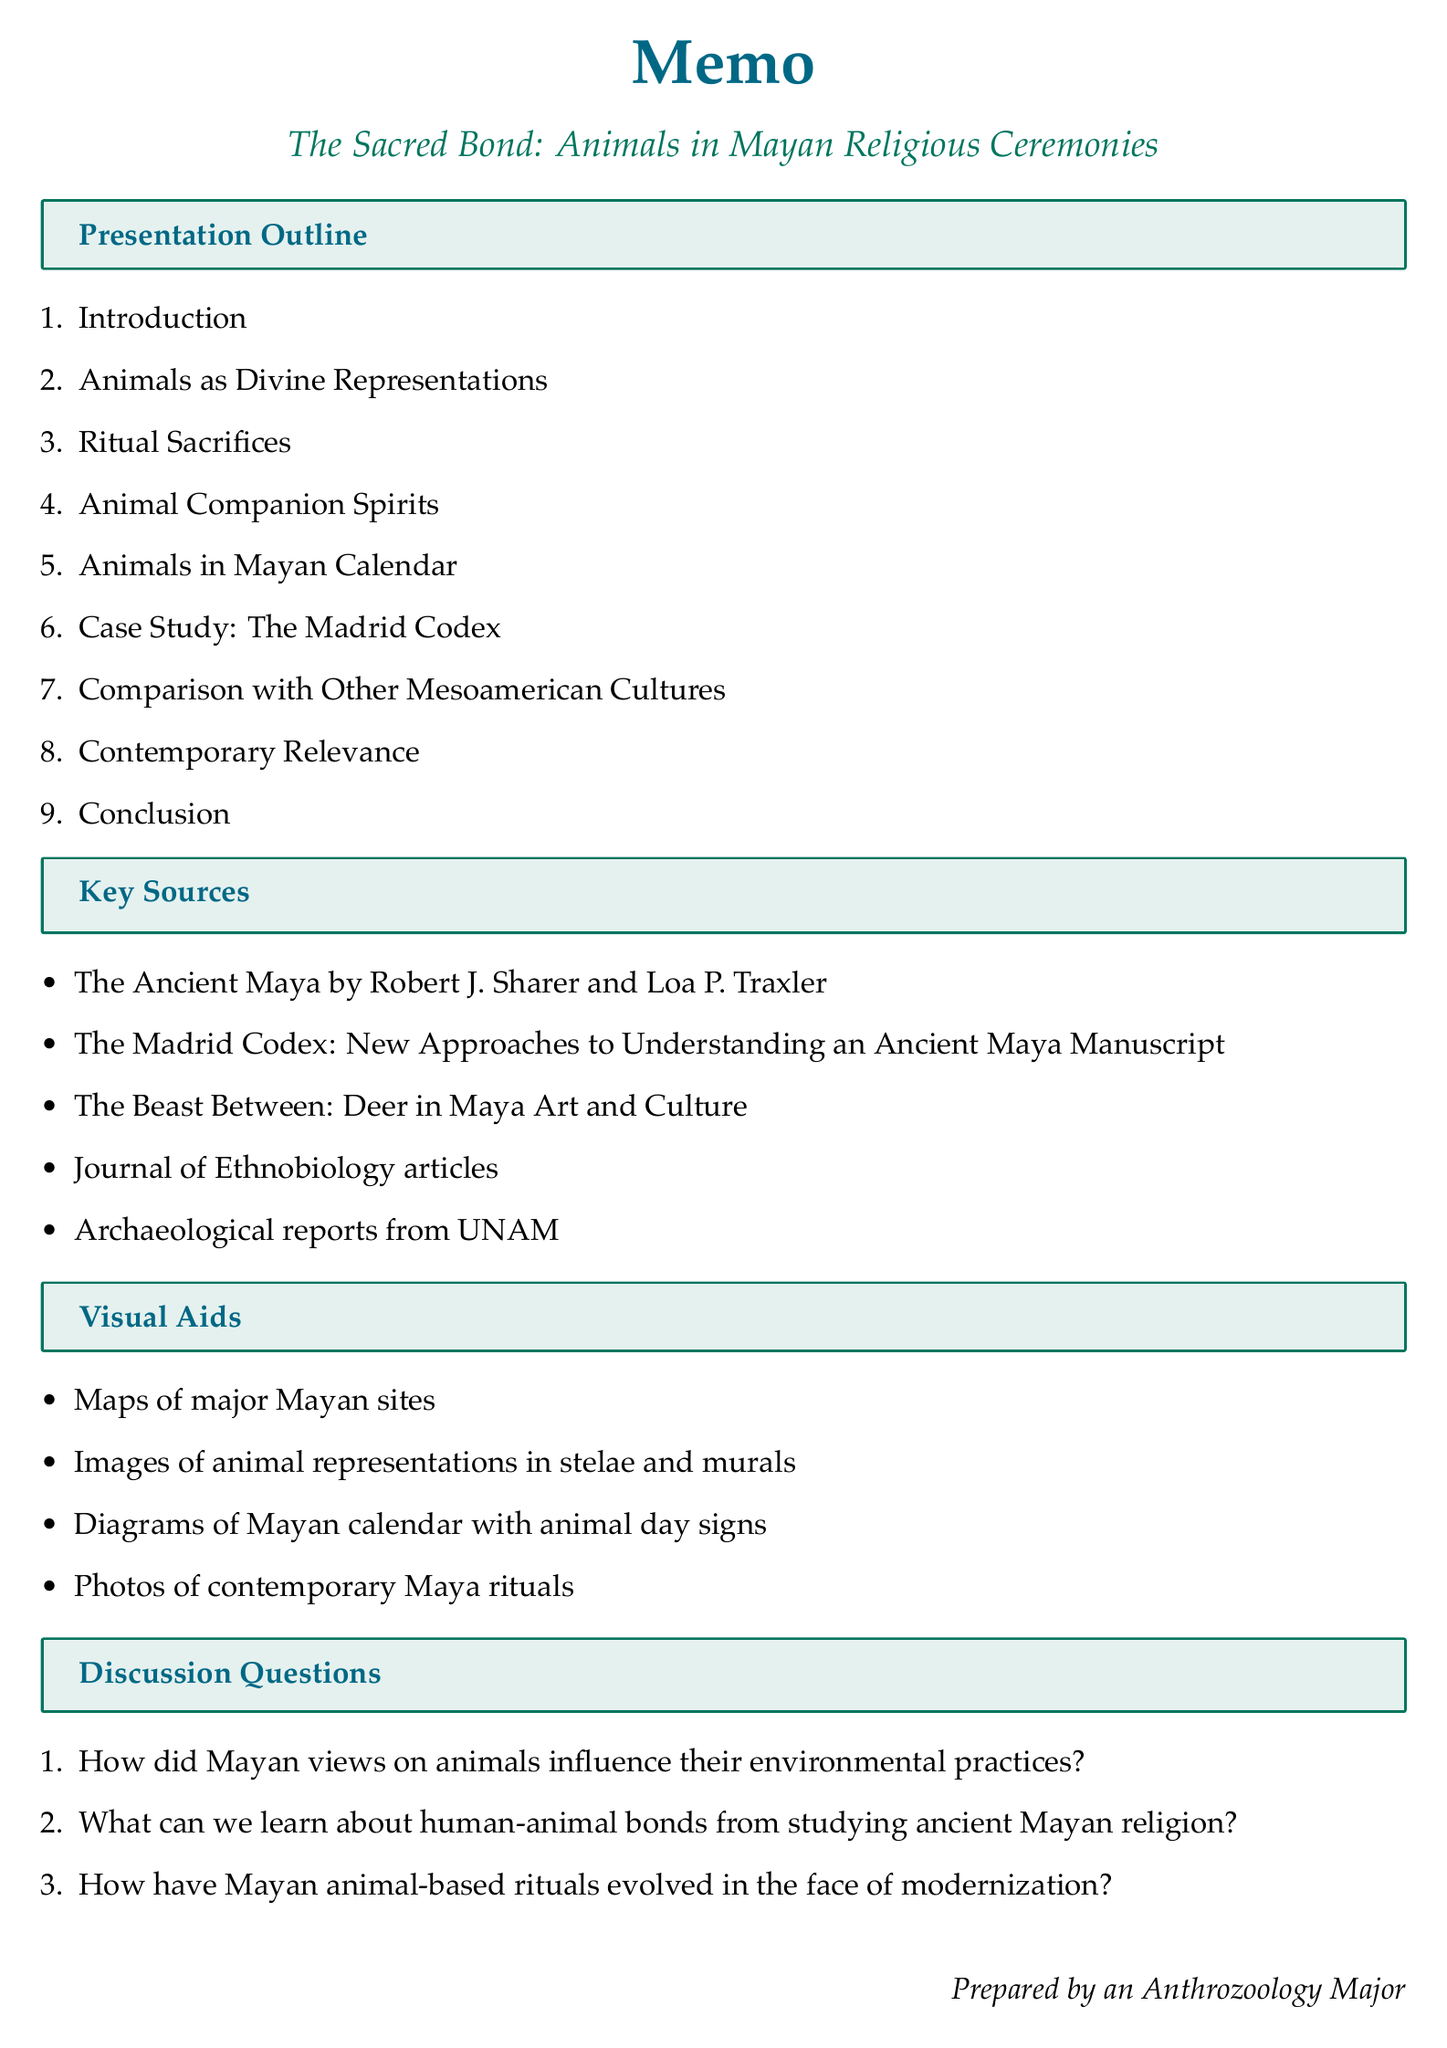What is the presentation title? The presentation title is explicitly stated at the beginning of the memo.
Answer: The Sacred Bond: Animals in Mayan Religious Ceremonies How many sections are in the outline? The number of sections can be counted in the outline provided in the document.
Answer: Nine What animal is a symbol of the night and underworld? The memo lists specific animals and their symbolic meanings under the section "Animals as Divine Representations."
Answer: Jaguar Which Mayan codex is mentioned in the case study? The document explicitly names the codex under the section designated for the case study.
Answer: The Madrid Codex What is one type of visual aid used in the presentation? The visual aids are listed in a dedicated section of the document, providing examples of what will be included.
Answer: Maps of major Mayan sites What concept relates to animal co-essence? The memorandum includes specific terminology under the section on Animal Companion Spirits.
Answer: 'way' How many discussion questions are presented? The total number of discussion questions can be obtained by counting them in the corresponding section.
Answer: Three What are the names of two key sources referenced? The document lists several key sources, and two can be easily extracted from the provided information.
Answer: The Ancient Maya, The Madrid Codex: New Approaches to Understanding an Ancient Maya Manuscript Which civilization is the focus of this presentation? This information is specified in the introductory section of the memo that sets the context for the discussion.
Answer: Mayan civilization 